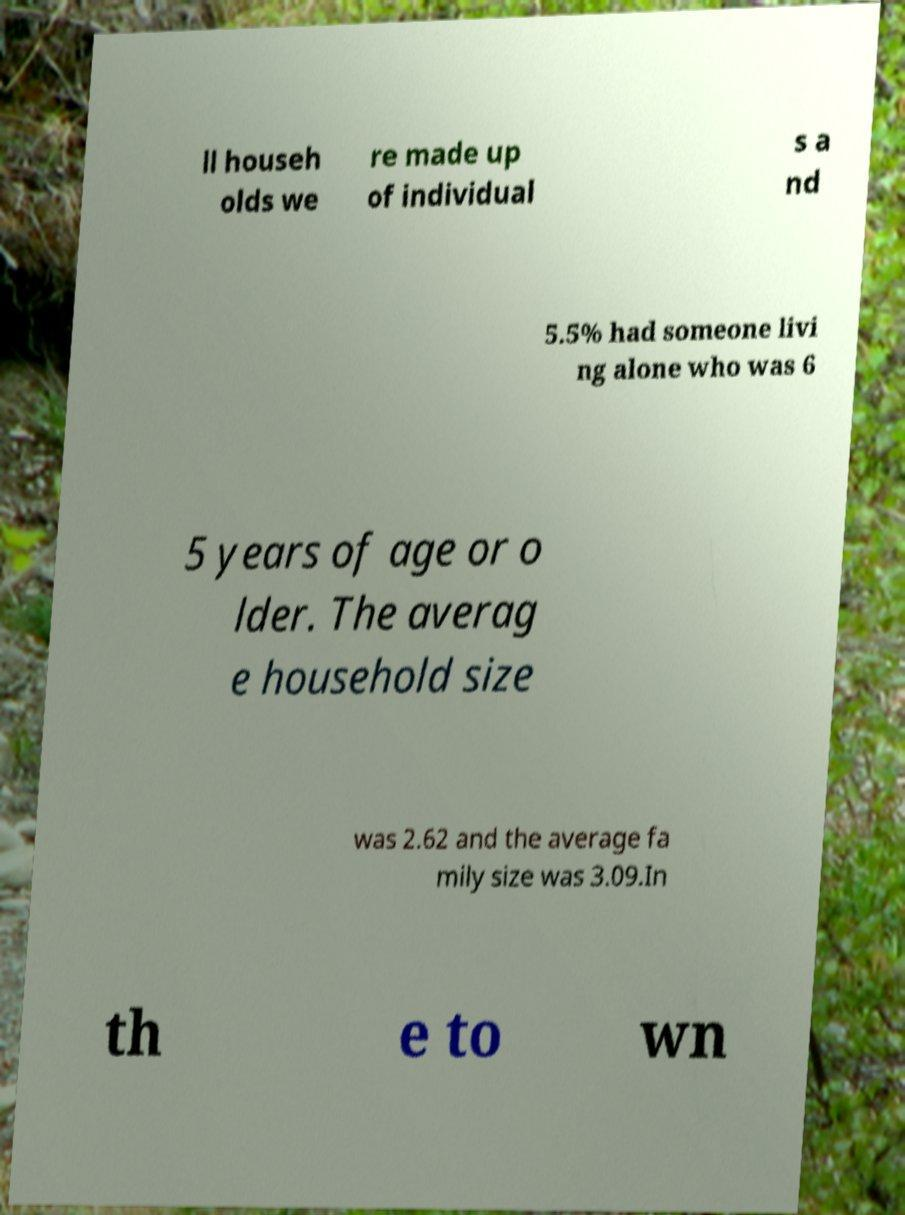I need the written content from this picture converted into text. Can you do that? ll househ olds we re made up of individual s a nd 5.5% had someone livi ng alone who was 6 5 years of age or o lder. The averag e household size was 2.62 and the average fa mily size was 3.09.In th e to wn 